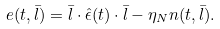<formula> <loc_0><loc_0><loc_500><loc_500>e ( t , \bar { l } ) = \bar { l } \cdot \hat { \epsilon } ( t ) \cdot \bar { l } - \eta _ { N } n ( t , \bar { l } ) .</formula> 